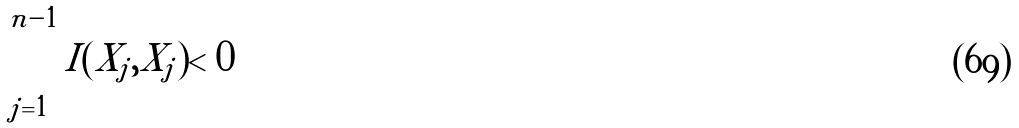Convert formula to latex. <formula><loc_0><loc_0><loc_500><loc_500>\sum _ { j = 1 } ^ { n - 1 } I ( X _ { j } , X _ { j } ) < 0</formula> 